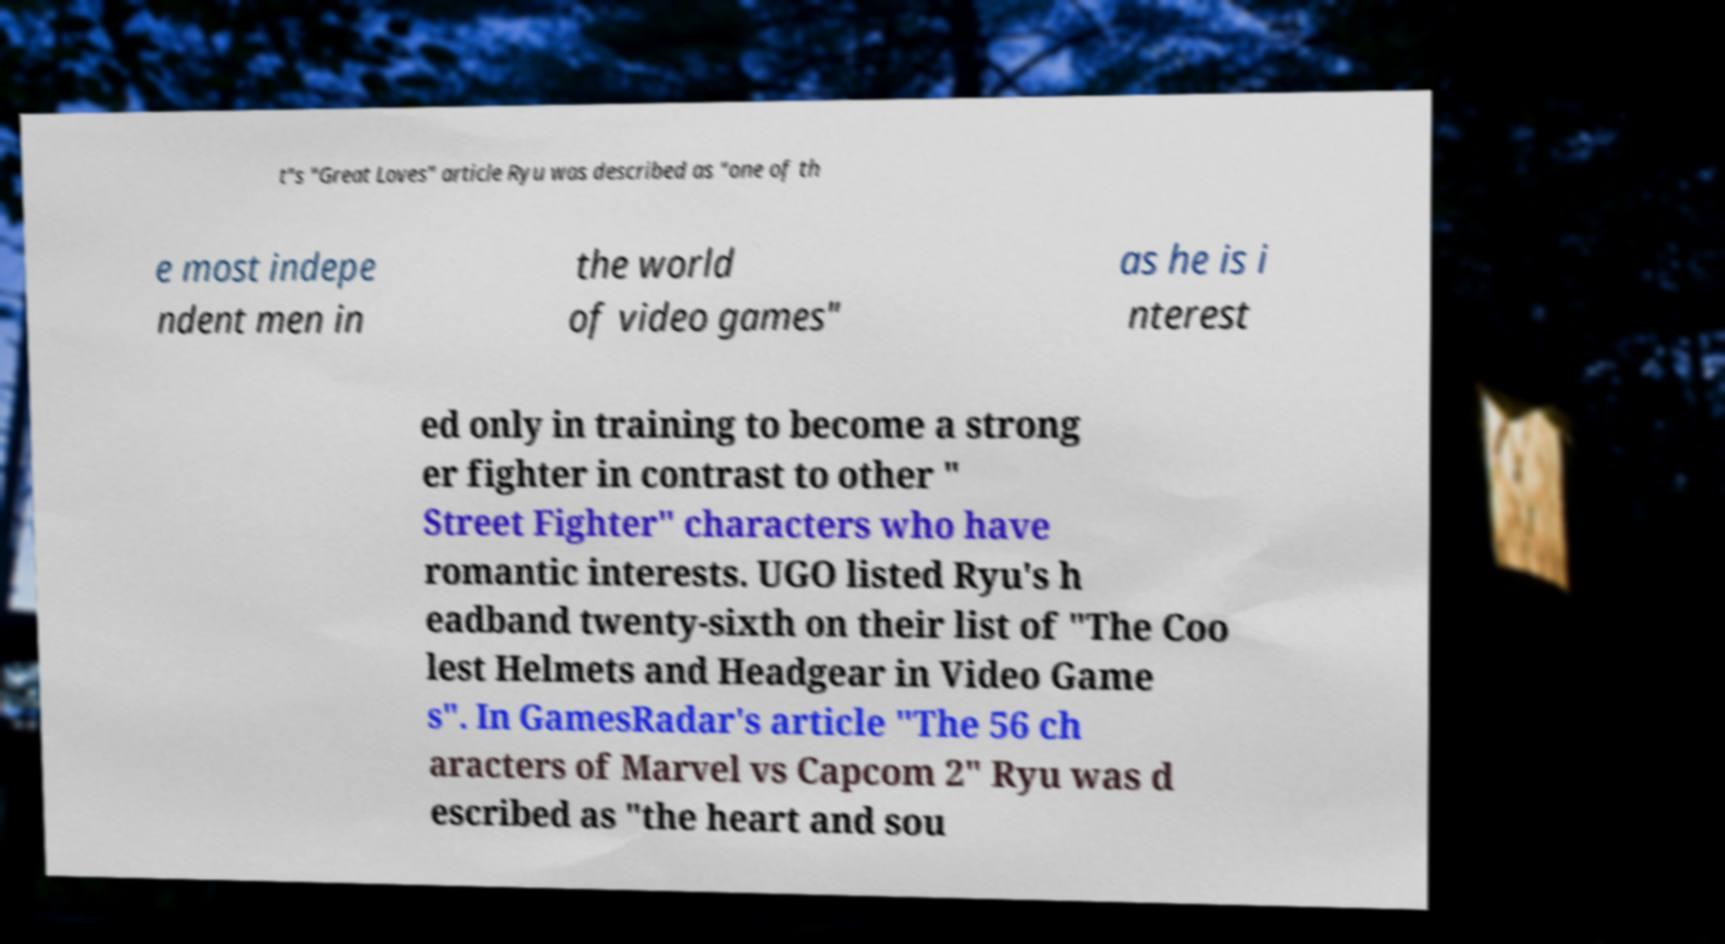I need the written content from this picture converted into text. Can you do that? t"s "Great Loves" article Ryu was described as "one of th e most indepe ndent men in the world of video games" as he is i nterest ed only in training to become a strong er fighter in contrast to other " Street Fighter" characters who have romantic interests. UGO listed Ryu's h eadband twenty-sixth on their list of "The Coo lest Helmets and Headgear in Video Game s". In GamesRadar's article "The 56 ch aracters of Marvel vs Capcom 2" Ryu was d escribed as "the heart and sou 